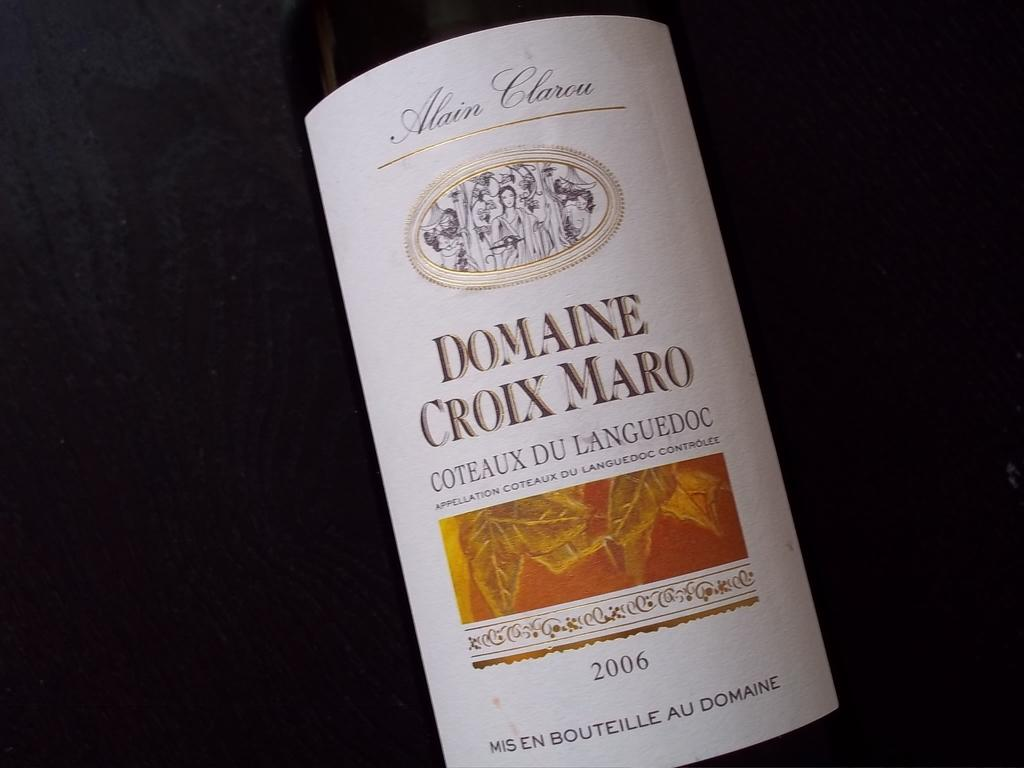<image>
Relay a brief, clear account of the picture shown. A 2006 bottle of Domaine Croix Maro is shown up close. 